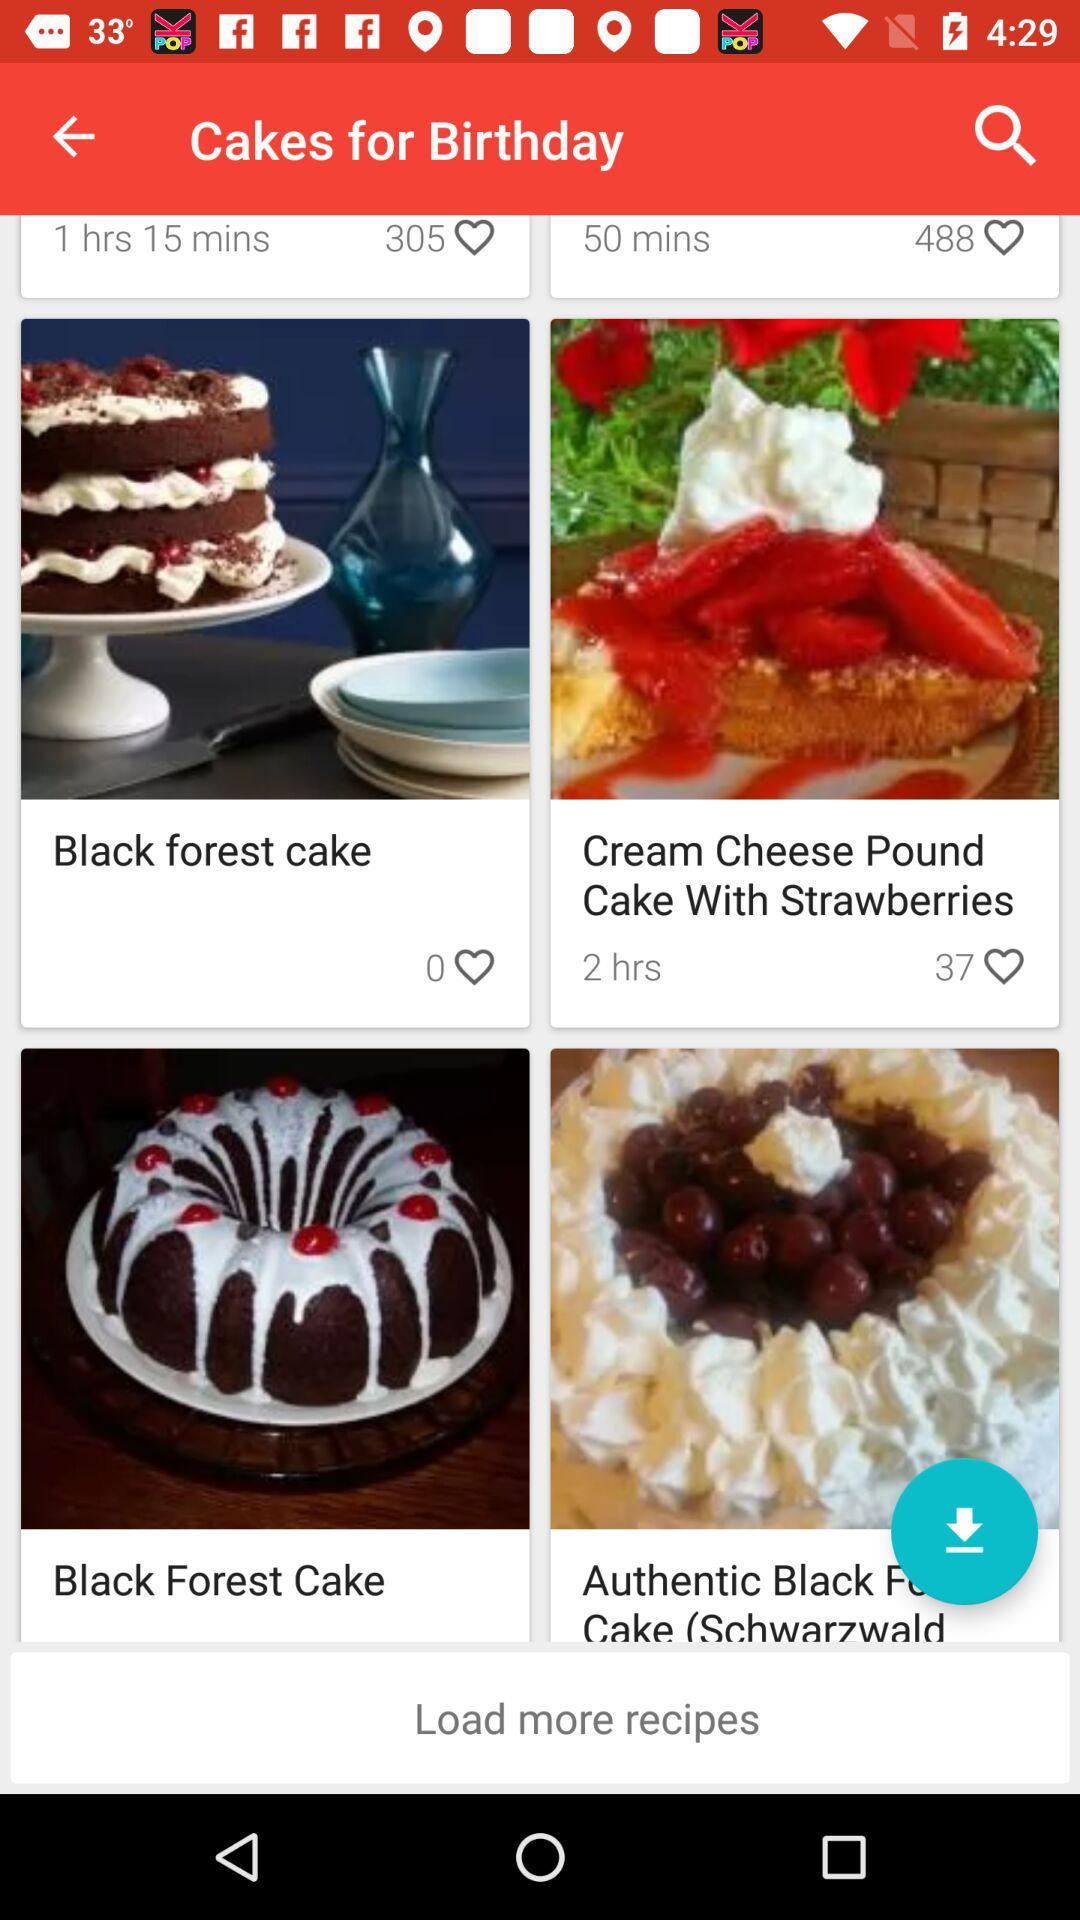What is the time duration for cream cheese pound cakes post?
When the provided information is insufficient, respond with <no answer>. <no answer> 